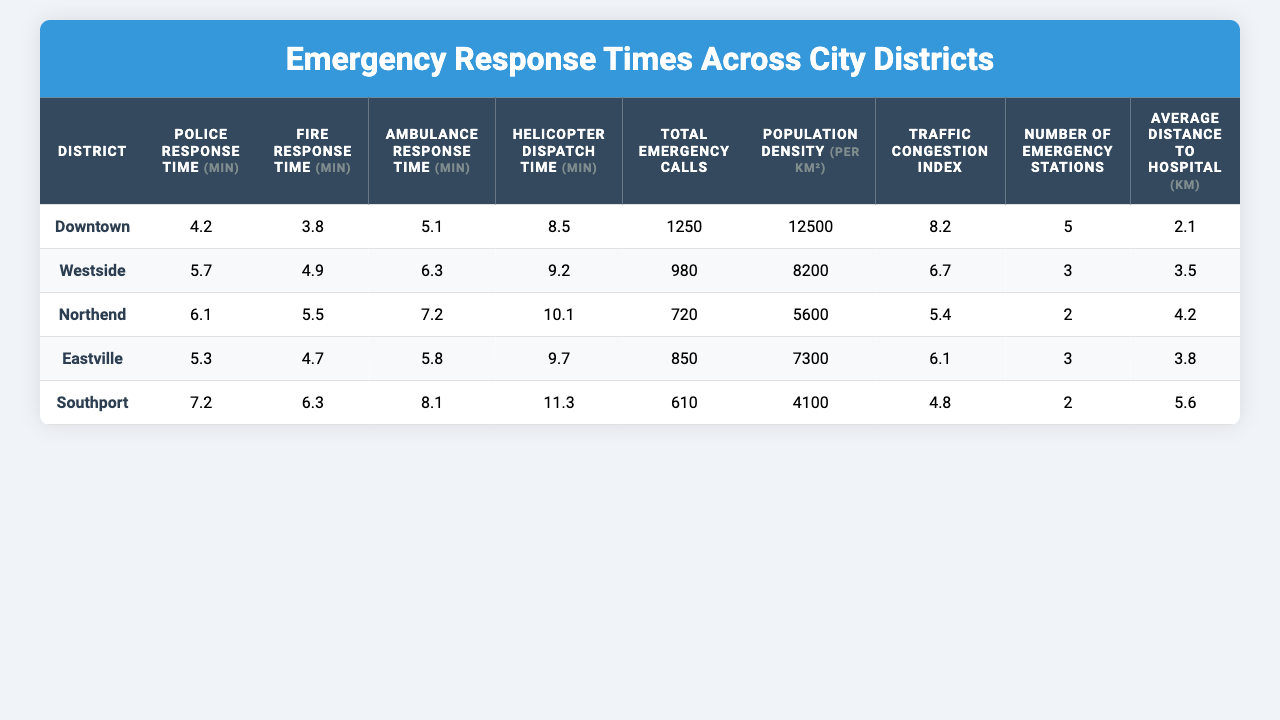What is the police response time in Downtown? The table shows that the police response time in Downtown is 4.2 minutes.
Answer: 4.2 minutes Which district has the highest ambulance response time? By reviewing the table, I can see that Southport has the highest ambulance response time at 8.1 minutes.
Answer: Southport What is the average fire response time across all districts? To find the average fire response time, I sum up the fire response times: (3.8 + 4.9 + 5.5 + 4.7 + 6.3) = 25.2. Then I divide by the number of districts (5): 25.2 / 5 = 5.04.
Answer: 5.04 minutes Is the traffic congestion index in Westside higher than that in Northend? The traffic congestion index in Westside is 6.7, while in Northend it is 5.4. Since 6.7 is greater than 5.4, the statement is true.
Answer: Yes What is the total number of emergency calls in all districts combined? I add together the total emergency calls for each district: (1250 + 980 + 720 + 850 + 610) = 4410.
Answer: 4410 calls Which district has the lowest population density? This can be found in the population density column. Southport has the lowest population density at 4100 per km².
Answer: Southport What is the difference in helicopter dispatch time between the Downtown and Southport districts? I find the helicopter dispatch time for Downtown, which is 8.5 minutes, and for Southport, which is 11.3 minutes. The difference is 11.3 - 8.5 = 2.8 minutes.
Answer: 2.8 minutes If the average distance to the hospital is 3 km or less, which districts meet this criterion? I check the average distance to the hospital for each district: Downtown (2.1), Westside (3.5), Northend (4.2), Eastville (3.8), and Southport (5.6). Only Downtown meets the criterion of being 3 km or less.
Answer: Downtown How many more emergency stations does Downtown have compared to Northend? Downtown has 5 emergency stations, while Northend has 2. The difference is 5 - 2 = 3 more stations in Downtown.
Answer: 3 more stations Is the average response time for ambulances longer than the average response time for police across all districts? First, I need to calculate the average ambulance response time (5.1 + 6.3 + 7.2 + 5.8 + 8.1 = 32.5; 32.5 / 5 = 6.5) and police response time (4.2 + 5.7 + 6.1 + 5.3 + 7.2 = 28.5; 28.5 / 5 = 5.7). Since 6.5 is greater than 5.7, this statement is true.
Answer: Yes What is the average response time for police in districts with over 8000 in population density? The districts with a population density over 8000 are Downtown and Westside. Their police response times are 4.2 and 5.7, respectively. Sum: (4.2 + 5.7) = 9.9; Average: 9.9 / 2 = 4.95.
Answer: 4.95 minutes 